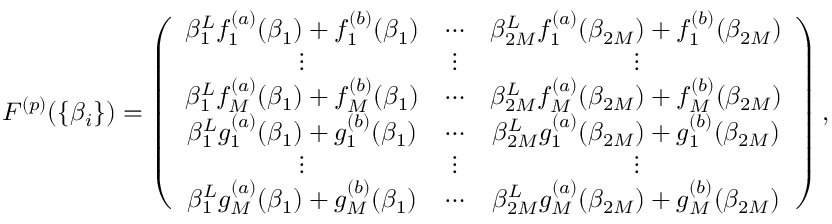Convert formula to latex. <formula><loc_0><loc_0><loc_500><loc_500>\begin{array} { r } { F ^ { ( p ) } ( \{ \beta _ { i } \} ) = \left ( \begin{array} { c c c c c c } { \beta _ { 1 } ^ { L } f _ { 1 } ^ { ( a ) } ( \beta _ { 1 } ) + f _ { 1 } ^ { ( b ) } ( \beta _ { 1 } ) } & { \cdots } & { \beta _ { 2 M } ^ { L } f _ { 1 } ^ { ( a ) } ( \beta _ { 2 M } ) + f _ { 1 } ^ { ( b ) } ( \beta _ { 2 M } ) } \\ { \vdots } & { \vdots } & { \vdots } \\ { \beta _ { 1 } ^ { L } f _ { M } ^ { ( a ) } ( \beta _ { 1 } ) + f _ { M } ^ { ( b ) } ( \beta _ { 1 } ) } & { \cdots } & { \beta _ { 2 M } ^ { L } f _ { M } ^ { ( a ) } ( \beta _ { 2 M } ) + f _ { M } ^ { ( b ) } ( \beta _ { 2 M } ) } \\ { \beta _ { 1 } ^ { L } g _ { 1 } ^ { ( a ) } ( \beta _ { 1 } ) + g _ { 1 } ^ { ( b ) } ( \beta _ { 1 } ) } & { \cdots } & { \beta _ { 2 M } ^ { L } g _ { 1 } ^ { ( a ) } ( \beta _ { 2 M } ) + g _ { 1 } ^ { ( b ) } ( \beta _ { 2 M } ) } \\ { \vdots } & { \vdots } & { \vdots } \\ { \beta _ { 1 } ^ { L } g _ { M } ^ { ( a ) } ( \beta _ { 1 } ) + g _ { M } ^ { ( b ) } ( \beta _ { 1 } ) } & { \cdots } & { \beta _ { 2 M } ^ { L } g _ { M } ^ { ( a ) } ( \beta _ { 2 M } ) + g _ { M } ^ { ( b ) } ( \beta _ { 2 M } ) } \end{array} \right ) , } \end{array}</formula> 